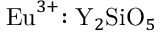<formula> <loc_0><loc_0><loc_500><loc_500>{ E u } ^ { 3 + } { \colon Y } _ { 2 } { S i O } _ { 5 }</formula> 